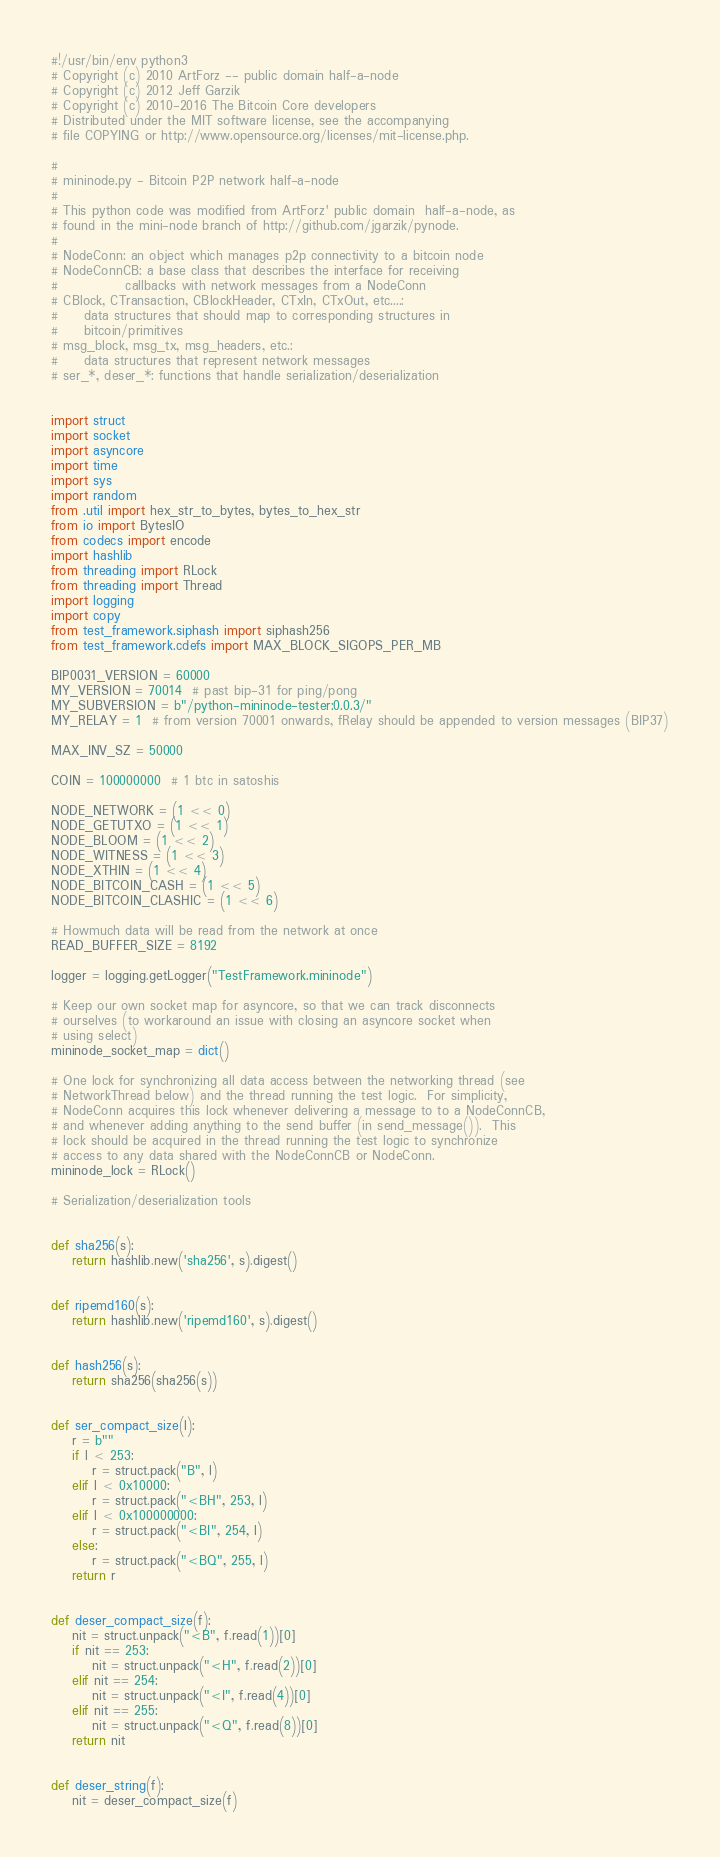<code> <loc_0><loc_0><loc_500><loc_500><_Python_>#!/usr/bin/env python3
# Copyright (c) 2010 ArtForz -- public domain half-a-node
# Copyright (c) 2012 Jeff Garzik
# Copyright (c) 2010-2016 The Bitcoin Core developers
# Distributed under the MIT software license, see the accompanying
# file COPYING or http://www.opensource.org/licenses/mit-license.php.

#
# mininode.py - Bitcoin P2P network half-a-node
#
# This python code was modified from ArtForz' public domain  half-a-node, as
# found in the mini-node branch of http://github.com/jgarzik/pynode.
#
# NodeConn: an object which manages p2p connectivity to a bitcoin node
# NodeConnCB: a base class that describes the interface for receiving
#             callbacks with network messages from a NodeConn
# CBlock, CTransaction, CBlockHeader, CTxIn, CTxOut, etc....:
#     data structures that should map to corresponding structures in
#     bitcoin/primitives
# msg_block, msg_tx, msg_headers, etc.:
#     data structures that represent network messages
# ser_*, deser_*: functions that handle serialization/deserialization


import struct
import socket
import asyncore
import time
import sys
import random
from .util import hex_str_to_bytes, bytes_to_hex_str
from io import BytesIO
from codecs import encode
import hashlib
from threading import RLock
from threading import Thread
import logging
import copy
from test_framework.siphash import siphash256
from test_framework.cdefs import MAX_BLOCK_SIGOPS_PER_MB

BIP0031_VERSION = 60000
MY_VERSION = 70014  # past bip-31 for ping/pong
MY_SUBVERSION = b"/python-mininode-tester:0.0.3/"
MY_RELAY = 1  # from version 70001 onwards, fRelay should be appended to version messages (BIP37)

MAX_INV_SZ = 50000

COIN = 100000000  # 1 btc in satoshis

NODE_NETWORK = (1 << 0)
NODE_GETUTXO = (1 << 1)
NODE_BLOOM = (1 << 2)
NODE_WITNESS = (1 << 3)
NODE_XTHIN = (1 << 4)
NODE_BITCOIN_CASH = (1 << 5)
NODE_BITCOIN_CLASHIC = (1 << 6)

# Howmuch data will be read from the network at once
READ_BUFFER_SIZE = 8192

logger = logging.getLogger("TestFramework.mininode")

# Keep our own socket map for asyncore, so that we can track disconnects
# ourselves (to workaround an issue with closing an asyncore socket when
# using select)
mininode_socket_map = dict()

# One lock for synchronizing all data access between the networking thread (see
# NetworkThread below) and the thread running the test logic.  For simplicity,
# NodeConn acquires this lock whenever delivering a message to to a NodeConnCB,
# and whenever adding anything to the send buffer (in send_message()).  This
# lock should be acquired in the thread running the test logic to synchronize
# access to any data shared with the NodeConnCB or NodeConn.
mininode_lock = RLock()

# Serialization/deserialization tools


def sha256(s):
    return hashlib.new('sha256', s).digest()


def ripemd160(s):
    return hashlib.new('ripemd160', s).digest()


def hash256(s):
    return sha256(sha256(s))


def ser_compact_size(l):
    r = b""
    if l < 253:
        r = struct.pack("B", l)
    elif l < 0x10000:
        r = struct.pack("<BH", 253, l)
    elif l < 0x100000000:
        r = struct.pack("<BI", 254, l)
    else:
        r = struct.pack("<BQ", 255, l)
    return r


def deser_compact_size(f):
    nit = struct.unpack("<B", f.read(1))[0]
    if nit == 253:
        nit = struct.unpack("<H", f.read(2))[0]
    elif nit == 254:
        nit = struct.unpack("<I", f.read(4))[0]
    elif nit == 255:
        nit = struct.unpack("<Q", f.read(8))[0]
    return nit


def deser_string(f):
    nit = deser_compact_size(f)</code> 